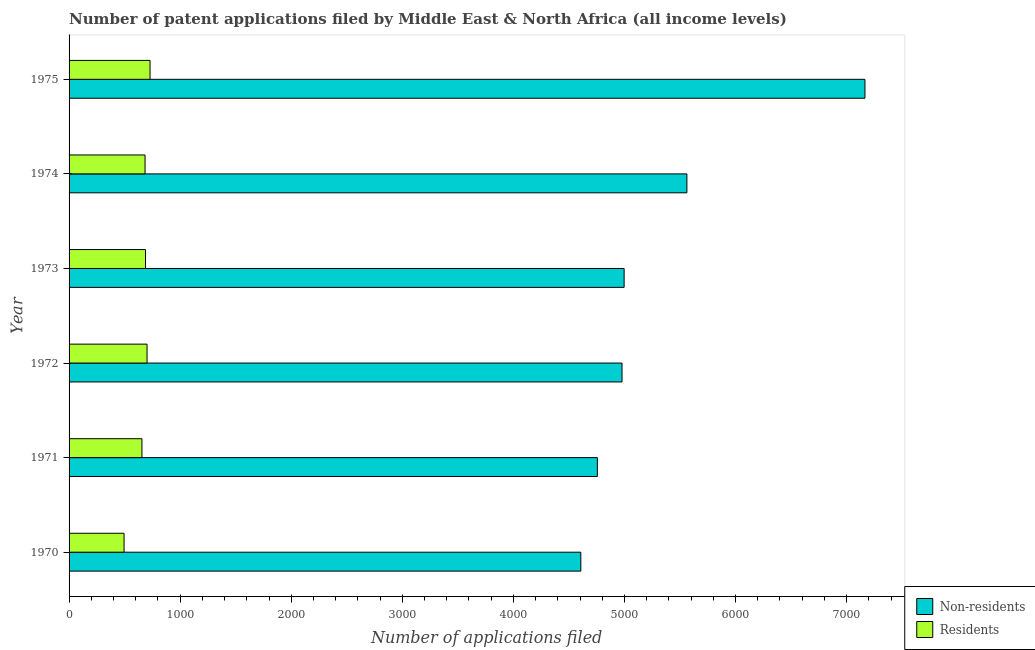How many groups of bars are there?
Provide a succinct answer. 6. Are the number of bars on each tick of the Y-axis equal?
Your answer should be very brief. Yes. How many bars are there on the 5th tick from the top?
Keep it short and to the point. 2. In how many cases, is the number of bars for a given year not equal to the number of legend labels?
Keep it short and to the point. 0. What is the number of patent applications by non residents in 1972?
Provide a short and direct response. 4978. Across all years, what is the maximum number of patent applications by residents?
Your response must be concise. 729. Across all years, what is the minimum number of patent applications by residents?
Offer a very short reply. 495. In which year was the number of patent applications by non residents maximum?
Offer a very short reply. 1975. In which year was the number of patent applications by non residents minimum?
Give a very brief answer. 1970. What is the total number of patent applications by residents in the graph?
Provide a short and direct response. 3954. What is the difference between the number of patent applications by residents in 1972 and that in 1973?
Make the answer very short. 14. What is the difference between the number of patent applications by non residents in 1975 and the number of patent applications by residents in 1972?
Offer a terse response. 6463. What is the average number of patent applications by non residents per year?
Keep it short and to the point. 5344.17. In the year 1972, what is the difference between the number of patent applications by residents and number of patent applications by non residents?
Your answer should be very brief. -4276. In how many years, is the number of patent applications by non residents greater than 1000 ?
Give a very brief answer. 6. What is the ratio of the number of patent applications by residents in 1970 to that in 1971?
Keep it short and to the point. 0.76. Is the number of patent applications by non residents in 1972 less than that in 1974?
Your answer should be very brief. Yes. Is the difference between the number of patent applications by residents in 1970 and 1973 greater than the difference between the number of patent applications by non residents in 1970 and 1973?
Keep it short and to the point. Yes. What is the difference between the highest and the second highest number of patent applications by non residents?
Offer a very short reply. 1603. What is the difference between the highest and the lowest number of patent applications by residents?
Your answer should be compact. 234. In how many years, is the number of patent applications by residents greater than the average number of patent applications by residents taken over all years?
Offer a terse response. 4. Is the sum of the number of patent applications by residents in 1970 and 1973 greater than the maximum number of patent applications by non residents across all years?
Your answer should be very brief. No. What does the 1st bar from the top in 1973 represents?
Give a very brief answer. Residents. What does the 1st bar from the bottom in 1973 represents?
Offer a terse response. Non-residents. What is the difference between two consecutive major ticks on the X-axis?
Ensure brevity in your answer.  1000. Does the graph contain any zero values?
Offer a very short reply. No. Where does the legend appear in the graph?
Give a very brief answer. Bottom right. How many legend labels are there?
Keep it short and to the point. 2. What is the title of the graph?
Your answer should be compact. Number of patent applications filed by Middle East & North Africa (all income levels). What is the label or title of the X-axis?
Offer a very short reply. Number of applications filed. What is the Number of applications filed of Non-residents in 1970?
Provide a short and direct response. 4607. What is the Number of applications filed of Residents in 1970?
Offer a very short reply. 495. What is the Number of applications filed of Non-residents in 1971?
Make the answer very short. 4756. What is the Number of applications filed of Residents in 1971?
Give a very brief answer. 656. What is the Number of applications filed of Non-residents in 1972?
Provide a short and direct response. 4978. What is the Number of applications filed in Residents in 1972?
Ensure brevity in your answer.  702. What is the Number of applications filed of Non-residents in 1973?
Offer a very short reply. 4997. What is the Number of applications filed in Residents in 1973?
Keep it short and to the point. 688. What is the Number of applications filed of Non-residents in 1974?
Your answer should be compact. 5562. What is the Number of applications filed in Residents in 1974?
Your answer should be compact. 684. What is the Number of applications filed in Non-residents in 1975?
Make the answer very short. 7165. What is the Number of applications filed of Residents in 1975?
Your response must be concise. 729. Across all years, what is the maximum Number of applications filed of Non-residents?
Offer a very short reply. 7165. Across all years, what is the maximum Number of applications filed in Residents?
Make the answer very short. 729. Across all years, what is the minimum Number of applications filed of Non-residents?
Keep it short and to the point. 4607. Across all years, what is the minimum Number of applications filed of Residents?
Ensure brevity in your answer.  495. What is the total Number of applications filed of Non-residents in the graph?
Provide a short and direct response. 3.21e+04. What is the total Number of applications filed in Residents in the graph?
Give a very brief answer. 3954. What is the difference between the Number of applications filed of Non-residents in 1970 and that in 1971?
Provide a succinct answer. -149. What is the difference between the Number of applications filed in Residents in 1970 and that in 1971?
Ensure brevity in your answer.  -161. What is the difference between the Number of applications filed in Non-residents in 1970 and that in 1972?
Your answer should be compact. -371. What is the difference between the Number of applications filed of Residents in 1970 and that in 1972?
Your answer should be very brief. -207. What is the difference between the Number of applications filed in Non-residents in 1970 and that in 1973?
Make the answer very short. -390. What is the difference between the Number of applications filed of Residents in 1970 and that in 1973?
Keep it short and to the point. -193. What is the difference between the Number of applications filed in Non-residents in 1970 and that in 1974?
Your response must be concise. -955. What is the difference between the Number of applications filed of Residents in 1970 and that in 1974?
Give a very brief answer. -189. What is the difference between the Number of applications filed of Non-residents in 1970 and that in 1975?
Provide a succinct answer. -2558. What is the difference between the Number of applications filed of Residents in 1970 and that in 1975?
Provide a short and direct response. -234. What is the difference between the Number of applications filed of Non-residents in 1971 and that in 1972?
Keep it short and to the point. -222. What is the difference between the Number of applications filed in Residents in 1971 and that in 1972?
Your response must be concise. -46. What is the difference between the Number of applications filed in Non-residents in 1971 and that in 1973?
Offer a terse response. -241. What is the difference between the Number of applications filed in Residents in 1971 and that in 1973?
Your response must be concise. -32. What is the difference between the Number of applications filed in Non-residents in 1971 and that in 1974?
Provide a succinct answer. -806. What is the difference between the Number of applications filed of Residents in 1971 and that in 1974?
Provide a short and direct response. -28. What is the difference between the Number of applications filed in Non-residents in 1971 and that in 1975?
Make the answer very short. -2409. What is the difference between the Number of applications filed in Residents in 1971 and that in 1975?
Provide a succinct answer. -73. What is the difference between the Number of applications filed of Non-residents in 1972 and that in 1974?
Keep it short and to the point. -584. What is the difference between the Number of applications filed of Non-residents in 1972 and that in 1975?
Offer a terse response. -2187. What is the difference between the Number of applications filed in Non-residents in 1973 and that in 1974?
Provide a short and direct response. -565. What is the difference between the Number of applications filed of Non-residents in 1973 and that in 1975?
Ensure brevity in your answer.  -2168. What is the difference between the Number of applications filed in Residents in 1973 and that in 1975?
Ensure brevity in your answer.  -41. What is the difference between the Number of applications filed of Non-residents in 1974 and that in 1975?
Offer a terse response. -1603. What is the difference between the Number of applications filed in Residents in 1974 and that in 1975?
Give a very brief answer. -45. What is the difference between the Number of applications filed in Non-residents in 1970 and the Number of applications filed in Residents in 1971?
Your response must be concise. 3951. What is the difference between the Number of applications filed in Non-residents in 1970 and the Number of applications filed in Residents in 1972?
Your answer should be compact. 3905. What is the difference between the Number of applications filed in Non-residents in 1970 and the Number of applications filed in Residents in 1973?
Offer a very short reply. 3919. What is the difference between the Number of applications filed of Non-residents in 1970 and the Number of applications filed of Residents in 1974?
Your response must be concise. 3923. What is the difference between the Number of applications filed in Non-residents in 1970 and the Number of applications filed in Residents in 1975?
Give a very brief answer. 3878. What is the difference between the Number of applications filed in Non-residents in 1971 and the Number of applications filed in Residents in 1972?
Your answer should be compact. 4054. What is the difference between the Number of applications filed of Non-residents in 1971 and the Number of applications filed of Residents in 1973?
Give a very brief answer. 4068. What is the difference between the Number of applications filed of Non-residents in 1971 and the Number of applications filed of Residents in 1974?
Make the answer very short. 4072. What is the difference between the Number of applications filed of Non-residents in 1971 and the Number of applications filed of Residents in 1975?
Your response must be concise. 4027. What is the difference between the Number of applications filed of Non-residents in 1972 and the Number of applications filed of Residents in 1973?
Give a very brief answer. 4290. What is the difference between the Number of applications filed in Non-residents in 1972 and the Number of applications filed in Residents in 1974?
Your response must be concise. 4294. What is the difference between the Number of applications filed in Non-residents in 1972 and the Number of applications filed in Residents in 1975?
Offer a very short reply. 4249. What is the difference between the Number of applications filed in Non-residents in 1973 and the Number of applications filed in Residents in 1974?
Make the answer very short. 4313. What is the difference between the Number of applications filed of Non-residents in 1973 and the Number of applications filed of Residents in 1975?
Offer a very short reply. 4268. What is the difference between the Number of applications filed in Non-residents in 1974 and the Number of applications filed in Residents in 1975?
Your response must be concise. 4833. What is the average Number of applications filed of Non-residents per year?
Keep it short and to the point. 5344.17. What is the average Number of applications filed in Residents per year?
Make the answer very short. 659. In the year 1970, what is the difference between the Number of applications filed in Non-residents and Number of applications filed in Residents?
Provide a succinct answer. 4112. In the year 1971, what is the difference between the Number of applications filed in Non-residents and Number of applications filed in Residents?
Keep it short and to the point. 4100. In the year 1972, what is the difference between the Number of applications filed of Non-residents and Number of applications filed of Residents?
Offer a very short reply. 4276. In the year 1973, what is the difference between the Number of applications filed of Non-residents and Number of applications filed of Residents?
Your answer should be very brief. 4309. In the year 1974, what is the difference between the Number of applications filed of Non-residents and Number of applications filed of Residents?
Give a very brief answer. 4878. In the year 1975, what is the difference between the Number of applications filed in Non-residents and Number of applications filed in Residents?
Provide a short and direct response. 6436. What is the ratio of the Number of applications filed of Non-residents in 1970 to that in 1971?
Give a very brief answer. 0.97. What is the ratio of the Number of applications filed in Residents in 1970 to that in 1971?
Your answer should be compact. 0.75. What is the ratio of the Number of applications filed in Non-residents in 1970 to that in 1972?
Ensure brevity in your answer.  0.93. What is the ratio of the Number of applications filed in Residents in 1970 to that in 1972?
Provide a short and direct response. 0.71. What is the ratio of the Number of applications filed of Non-residents in 1970 to that in 1973?
Provide a short and direct response. 0.92. What is the ratio of the Number of applications filed of Residents in 1970 to that in 1973?
Make the answer very short. 0.72. What is the ratio of the Number of applications filed of Non-residents in 1970 to that in 1974?
Your answer should be very brief. 0.83. What is the ratio of the Number of applications filed of Residents in 1970 to that in 1974?
Keep it short and to the point. 0.72. What is the ratio of the Number of applications filed in Non-residents in 1970 to that in 1975?
Offer a terse response. 0.64. What is the ratio of the Number of applications filed of Residents in 1970 to that in 1975?
Make the answer very short. 0.68. What is the ratio of the Number of applications filed of Non-residents in 1971 to that in 1972?
Your response must be concise. 0.96. What is the ratio of the Number of applications filed of Residents in 1971 to that in 1972?
Your response must be concise. 0.93. What is the ratio of the Number of applications filed in Non-residents in 1971 to that in 1973?
Provide a short and direct response. 0.95. What is the ratio of the Number of applications filed of Residents in 1971 to that in 1973?
Provide a succinct answer. 0.95. What is the ratio of the Number of applications filed of Non-residents in 1971 to that in 1974?
Your answer should be compact. 0.86. What is the ratio of the Number of applications filed of Residents in 1971 to that in 1974?
Give a very brief answer. 0.96. What is the ratio of the Number of applications filed in Non-residents in 1971 to that in 1975?
Offer a very short reply. 0.66. What is the ratio of the Number of applications filed of Residents in 1971 to that in 1975?
Keep it short and to the point. 0.9. What is the ratio of the Number of applications filed in Non-residents in 1972 to that in 1973?
Your answer should be compact. 1. What is the ratio of the Number of applications filed of Residents in 1972 to that in 1973?
Offer a very short reply. 1.02. What is the ratio of the Number of applications filed of Non-residents in 1972 to that in 1974?
Give a very brief answer. 0.9. What is the ratio of the Number of applications filed in Residents in 1972 to that in 1974?
Your response must be concise. 1.03. What is the ratio of the Number of applications filed of Non-residents in 1972 to that in 1975?
Offer a very short reply. 0.69. What is the ratio of the Number of applications filed of Residents in 1972 to that in 1975?
Your answer should be very brief. 0.96. What is the ratio of the Number of applications filed of Non-residents in 1973 to that in 1974?
Offer a terse response. 0.9. What is the ratio of the Number of applications filed in Non-residents in 1973 to that in 1975?
Your answer should be very brief. 0.7. What is the ratio of the Number of applications filed in Residents in 1973 to that in 1975?
Keep it short and to the point. 0.94. What is the ratio of the Number of applications filed of Non-residents in 1974 to that in 1975?
Your answer should be compact. 0.78. What is the ratio of the Number of applications filed in Residents in 1974 to that in 1975?
Offer a very short reply. 0.94. What is the difference between the highest and the second highest Number of applications filed of Non-residents?
Provide a short and direct response. 1603. What is the difference between the highest and the lowest Number of applications filed in Non-residents?
Ensure brevity in your answer.  2558. What is the difference between the highest and the lowest Number of applications filed of Residents?
Your answer should be very brief. 234. 